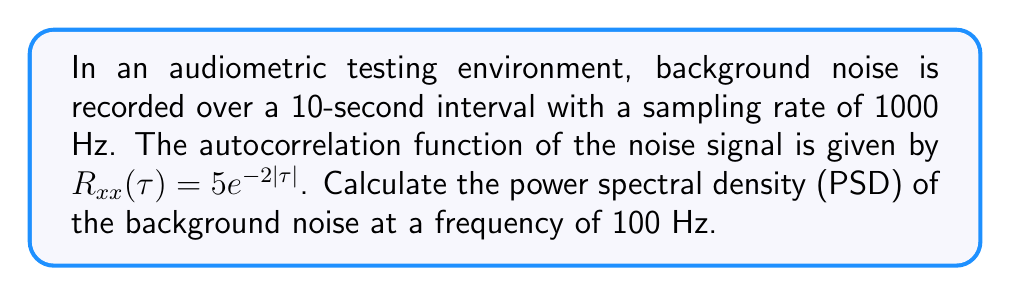Can you answer this question? To solve this problem, we'll follow these steps:

1) The power spectral density (PSD) is the Fourier transform of the autocorrelation function. For a continuous-time signal, the relationship is given by:

   $$S_{xx}(f) = \int_{-\infty}^{\infty} R_{xx}(\tau) e^{-j2\pi f\tau} d\tau$$

2) Given the autocorrelation function $R_{xx}(\tau) = 5e^{-2|\tau|}$, we can calculate the PSD:

   $$S_{xx}(f) = \int_{-\infty}^{\infty} 5e^{-2|\tau|} e^{-j2\pi f\tau} d\tau$$

3) This integral can be split into two parts:

   $$S_{xx}(f) = 5\int_{0}^{\infty} e^{-2\tau} e^{-j2\pi f\tau} d\tau + 5\int_{-\infty}^{0} e^{2\tau} e^{-j2\pi f\tau} d\tau$$

4) Solving these integrals:

   $$S_{xx}(f) = \frac{5}{2+j2\pi f} + \frac{5}{2-j2\pi f} = \frac{10(2-j2\pi f) + 10(2+j2\pi f)}{(2+j2\pi f)(2-j2\pi f)}$$

5) Simplifying:

   $$S_{xx}(f) = \frac{40}{4+(2\pi f)^2}$$

6) Now, we need to calculate this for f = 100 Hz:

   $$S_{xx}(100) = \frac{40}{4+(2\pi(100))^2} = \frac{40}{4+394784} \approx 0.0001013$$

7) The units of PSD are power per Hz, which in this case would be $V^2/Hz$ assuming the original signal was measured in volts.
Answer: $0.0001013$ $V^2/Hz$ 